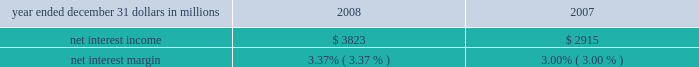Consolidated income statement review our consolidated income statement is presented in item 8 of this report .
Net income for 2008 was $ 882 million and for 2007 was $ 1.467 billion .
Total revenue for 2008 increased 7% ( 7 % ) compared with 2007 .
We created positive operating leverage in the year-to-date comparison as total noninterest expense increased 3% ( 3 % ) in the comparison .
Net interest income and net interest margin year ended december 31 dollars in millions 2008 2007 .
Changes in net interest income and margin result from the interaction of the volume and composition of interest-earning assets and related yields , interest-bearing liabilities and related rates paid , and noninterest-bearing sources of funding .
See statistical information 2013 analysis of year-to-year changes in net interest ( unaudited ) income and average consolidated balance sheet and net interest analysis in item 8 of this report for additional information .
The 31% ( 31 % ) increase in net interest income for 2008 compared with 2007 was favorably impacted by the $ 16.5 billion , or 17% ( 17 % ) , increase in average interest-earning assets and a decrease in funding costs .
The 2008 net interest margin was positively affected by declining rates paid on deposits and borrowings compared with the prior year .
The reasons driving the higher interest-earning assets in these comparisons are further discussed in the balance sheet highlights portion of the executive summary section of this item 7 .
The net interest margin was 3.37% ( 3.37 % ) for 2008 and 3.00% ( 3.00 % ) for 2007 .
The following factors impacted the comparison : 2022 a decrease in the rate paid on interest-bearing liabilities of 140 basis points .
The rate paid on interest-bearing deposits , the single largest component , decreased 123 basis points .
2022 these factors were partially offset by a 77 basis point decrease in the yield on interest-earning assets .
The yield on loans , the single largest component , decreased 109 basis points .
2022 in addition , the impact of noninterest-bearing sources of funding decreased 26 basis points due to lower interest rates and a lower proportion of noninterest- bearing sources of funding to interest-earning assets .
For comparing to the broader market , during 2008 the average federal funds rate was 1.94% ( 1.94 % ) compared with 5.03% ( 5.03 % ) for 2007 .
We expect our full-year 2009 net interest income to benefit from the impact of interest accretion of discounts resulting from purchase accounting marks and deposit pricing alignment related to our national city acquisition .
We also currently expect our 2009 net interest margin to improve on a year-over-year basis .
Noninterest income summary noninterest income was $ 3.367 billion for 2008 and $ 3.790 billion for 2007 .
Noninterest income for 2008 included the following : 2022 gains of $ 246 million related to the mark-to-market adjustment on our blackrock ltip shares obligation , 2022 losses related to our commercial mortgage loans held for sale of $ 197 million , net of hedges , 2022 impairment and other losses related to alternative investments of $ 179 million , 2022 income from hilliard lyons totaling $ 164 million , including the first quarter gain of $ 114 million from the sale of this business , 2022 net securities losses of $ 206 million , 2022 a first quarter gain of $ 95 million related to the redemption of a portion of our visa class b common shares related to visa 2019s march 2008 initial public offering , 2022 a third quarter $ 61 million reversal of a legal contingency reserve established in connection with an acquisition due to a settlement , 2022 trading losses of $ 55 million , 2022 a $ 35 million impairment charge on commercial mortgage servicing rights , and 2022 equity management losses of $ 24 million .
Noninterest income for 2007 included the following : 2022 the impact of $ 82 million gain recognized in connection with our transfer of blackrock shares to satisfy a portion of pnc 2019s ltip obligation and a $ 209 million net loss on our ltip shares obligation , 2022 income from hilliard lyons totaling $ 227 million , 2022 trading income of $ 104 million , 2022 equity management gains of $ 102 million , and 2022 gains related to our commercial mortgage loans held for sale of $ 3 million , net of hedges .
Apart from the impact of these items , noninterest income increased $ 16 million in 2008 compared with 2007 .
Additional analysis fund servicing fees increased $ 69 million in 2008 , to $ 904 million , compared with $ 835 million in 2007 .
The impact of the december 2007 acquisition of albridge solutions inc .
( 201calbridge solutions 201d ) and growth in global investment servicing 2019s offshore operations were the primary drivers of this increase .
Global investment servicing provided fund accounting/ administration services for $ 839 billion of net fund investment assets and provided custody services for $ 379 billion of fund .
Between 2008 and 2007 , what was the change in net interest income in millions? 
Computations: (3823 - 2915)
Answer: 908.0. 